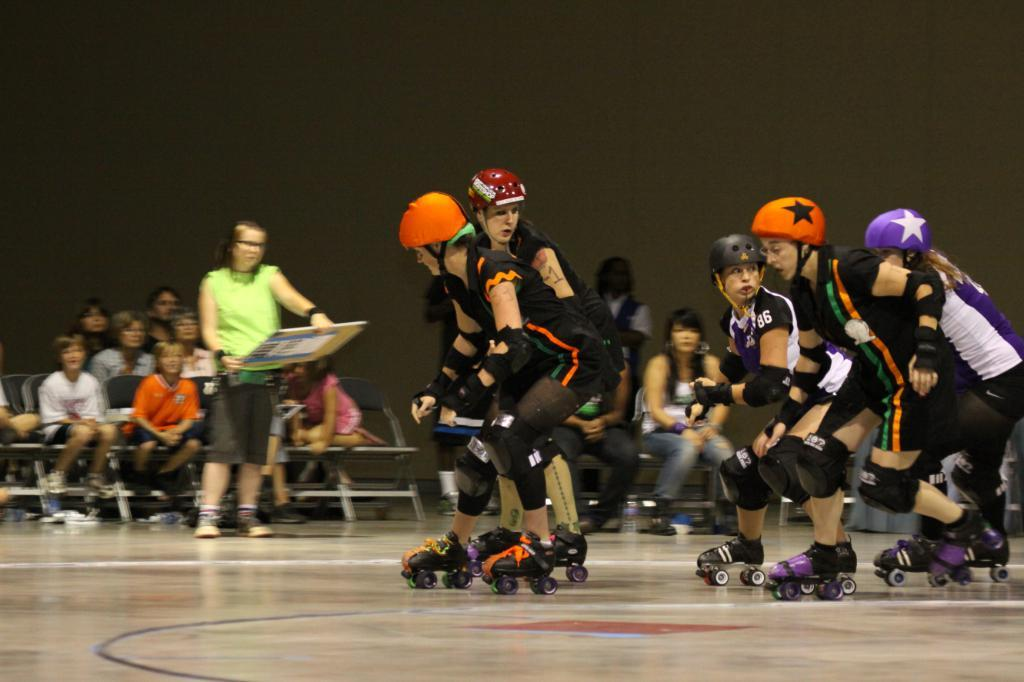What are the people in the image doing? The people in the image are skating. What are the people wearing on their heads? The people are wearing multi-color helmets. Can you describe the background of the image? In the background of the image, there are people, some of whom are sitting and some of whom are standing. What type of fuel is being used by the goat in the image? There is no goat present in the image, so it is not possible to determine what type of fuel it might be using. 